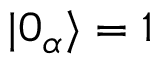Convert formula to latex. <formula><loc_0><loc_0><loc_500><loc_500>| 0 _ { \alpha } \rangle = 1</formula> 